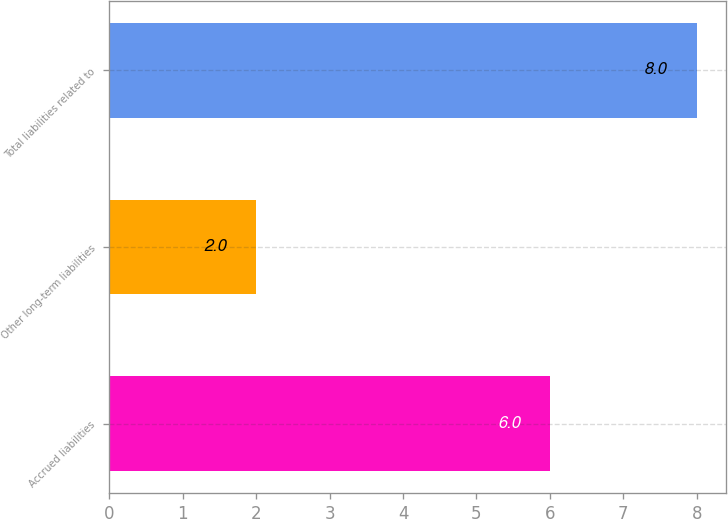Convert chart to OTSL. <chart><loc_0><loc_0><loc_500><loc_500><bar_chart><fcel>Accrued liabilities<fcel>Other long-term liabilities<fcel>Total liabilities related to<nl><fcel>6<fcel>2<fcel>8<nl></chart> 